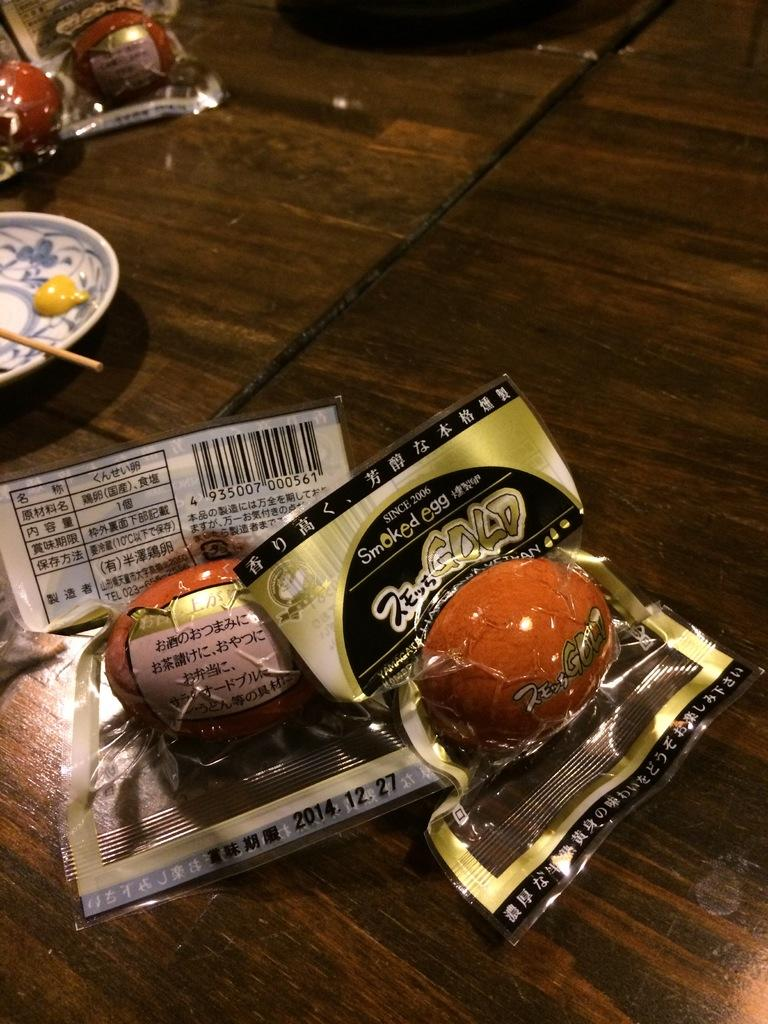What is present in the image that is typically used for cooking or baking? There are eggs in the image, which are commonly used for cooking or baking. How are the eggs stored or protected in the image? The eggs are packed in a cover to protect them. Where are the eggs located in the image? The eggs are kept on a table. What material is the table made of in the image? The table is made of wood. What is the rate at which the eggs are being consumed in the image? There is no indication of the rate at which the eggs are being consumed in the image; it only shows the eggs packed in a cover and placed on a wooden table. 